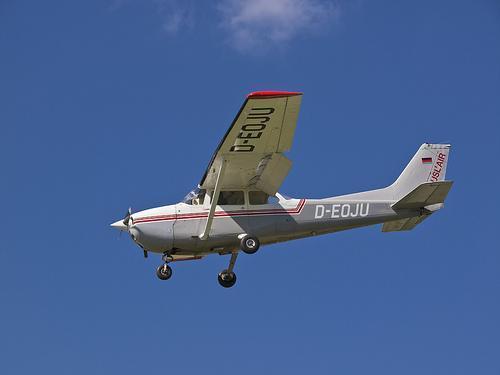How many planes are in the picture?
Give a very brief answer. 1. How many wheels are on the plane?
Give a very brief answer. 3. 